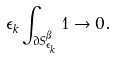Convert formula to latex. <formula><loc_0><loc_0><loc_500><loc_500>\epsilon _ { k } \int _ { \partial S _ { \epsilon _ { k } } ^ { \beta } } 1 \to 0 .</formula> 